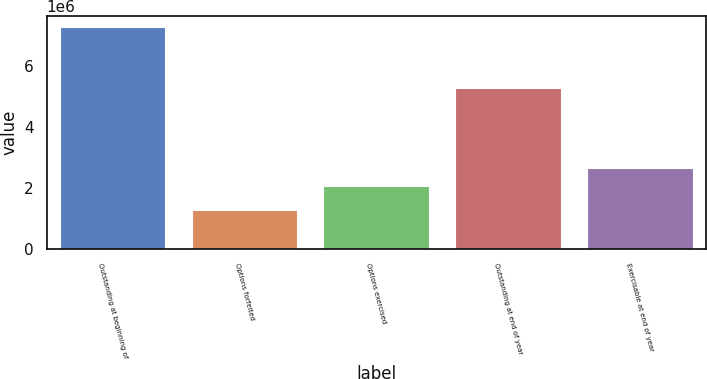Convert chart. <chart><loc_0><loc_0><loc_500><loc_500><bar_chart><fcel>Outstanding at beginning of<fcel>Options forfeited<fcel>Options exercised<fcel>Outstanding at end of year<fcel>Exercisable at end of year<nl><fcel>7.26829e+06<fcel>1.28637e+06<fcel>2.06179e+06<fcel>5.27412e+06<fcel>2.65999e+06<nl></chart> 